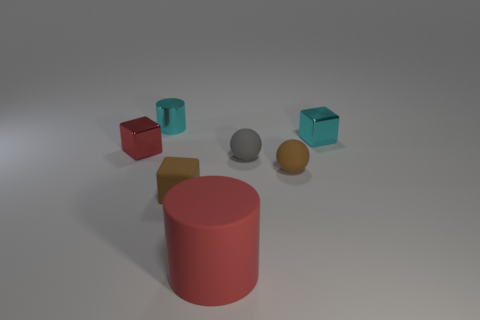Add 1 small brown rubber things. How many objects exist? 8 Subtract all cylinders. How many objects are left? 5 Subtract all tiny purple metallic objects. Subtract all gray matte spheres. How many objects are left? 6 Add 2 large cylinders. How many large cylinders are left? 3 Add 1 shiny objects. How many shiny objects exist? 4 Subtract 0 purple balls. How many objects are left? 7 